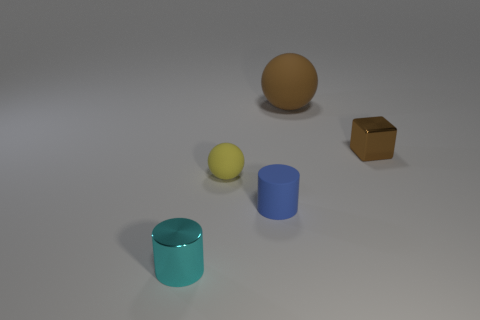Add 2 big gray cubes. How many objects exist? 7 Subtract 0 green balls. How many objects are left? 5 Subtract all spheres. How many objects are left? 3 Subtract all tiny green metal cubes. Subtract all small metallic cylinders. How many objects are left? 4 Add 1 rubber balls. How many rubber balls are left? 3 Add 1 yellow rubber things. How many yellow rubber things exist? 2 